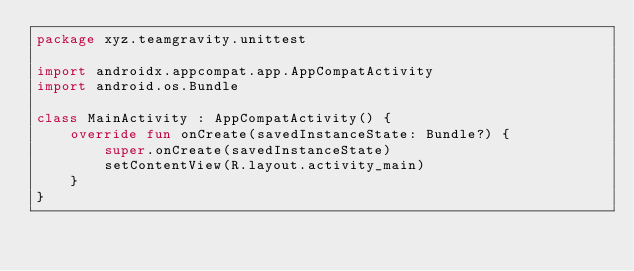<code> <loc_0><loc_0><loc_500><loc_500><_Kotlin_>package xyz.teamgravity.unittest

import androidx.appcompat.app.AppCompatActivity
import android.os.Bundle

class MainActivity : AppCompatActivity() {
    override fun onCreate(savedInstanceState: Bundle?) {
        super.onCreate(savedInstanceState)
        setContentView(R.layout.activity_main)
    }
}</code> 